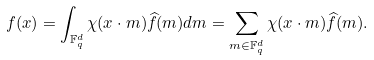<formula> <loc_0><loc_0><loc_500><loc_500>f ( x ) = \int _ { \mathbb { F } _ { q } ^ { d } } \chi ( x \cdot m ) \widehat { f } ( m ) d m = \sum _ { m \in \mathbb { F } _ { q } ^ { d } } \chi ( x \cdot m ) \widehat { f } ( m ) .</formula> 